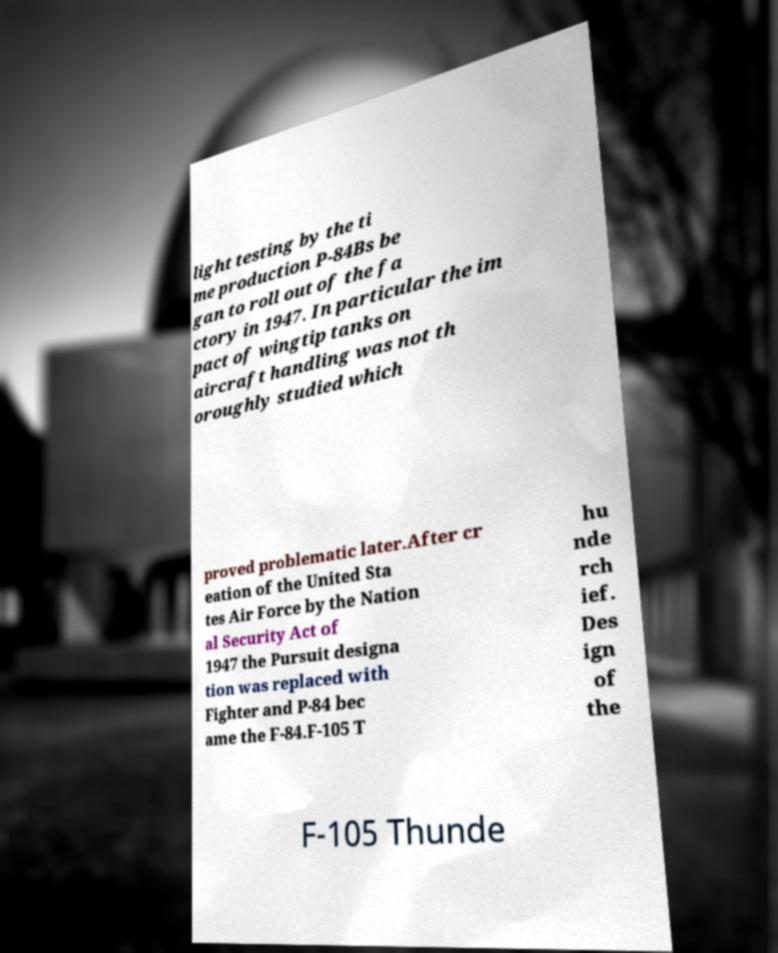Please read and relay the text visible in this image. What does it say? light testing by the ti me production P-84Bs be gan to roll out of the fa ctory in 1947. In particular the im pact of wingtip tanks on aircraft handling was not th oroughly studied which proved problematic later.After cr eation of the United Sta tes Air Force by the Nation al Security Act of 1947 the Pursuit designa tion was replaced with Fighter and P-84 bec ame the F-84.F-105 T hu nde rch ief. Des ign of the F-105 Thunde 